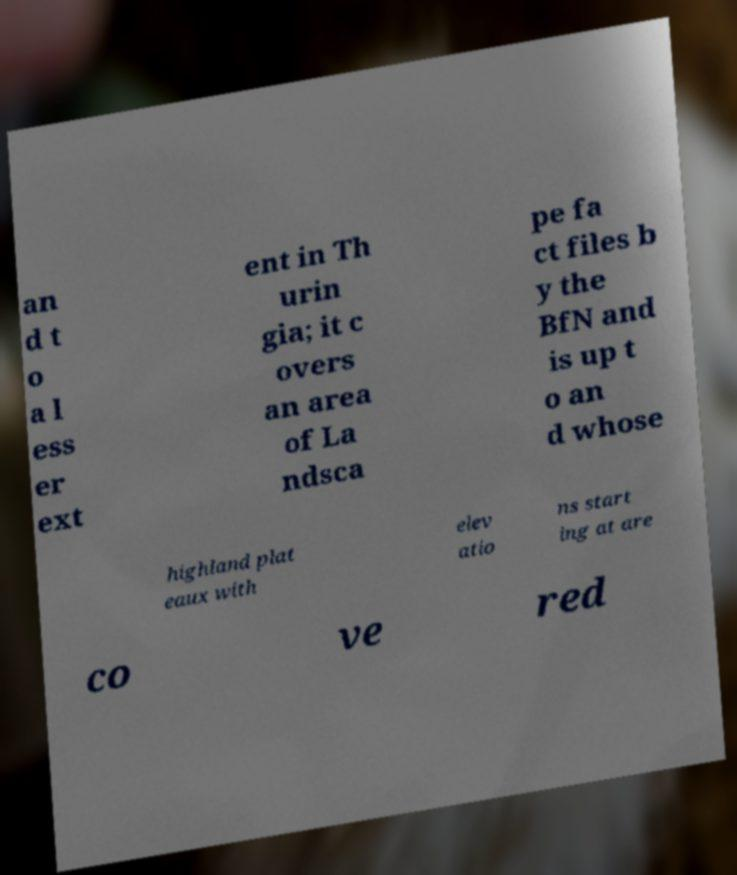Could you extract and type out the text from this image? an d t o a l ess er ext ent in Th urin gia; it c overs an area of La ndsca pe fa ct files b y the BfN and is up t o an d whose highland plat eaux with elev atio ns start ing at are co ve red 